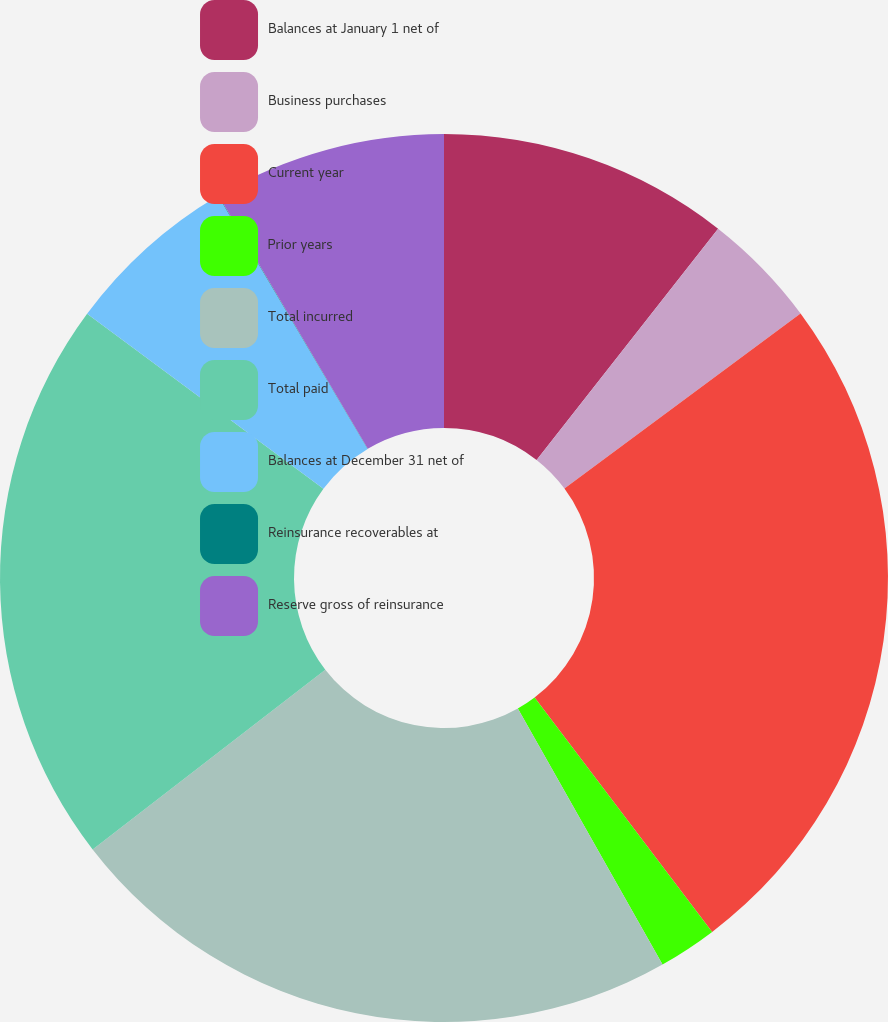Convert chart. <chart><loc_0><loc_0><loc_500><loc_500><pie_chart><fcel>Balances at January 1 net of<fcel>Business purchases<fcel>Current year<fcel>Prior years<fcel>Total incurred<fcel>Total paid<fcel>Balances at December 31 net of<fcel>Reinsurance recoverables at<fcel>Reserve gross of reinsurance<nl><fcel>10.59%<fcel>4.25%<fcel>24.84%<fcel>2.13%<fcel>22.72%<fcel>20.61%<fcel>6.36%<fcel>0.02%<fcel>8.48%<nl></chart> 